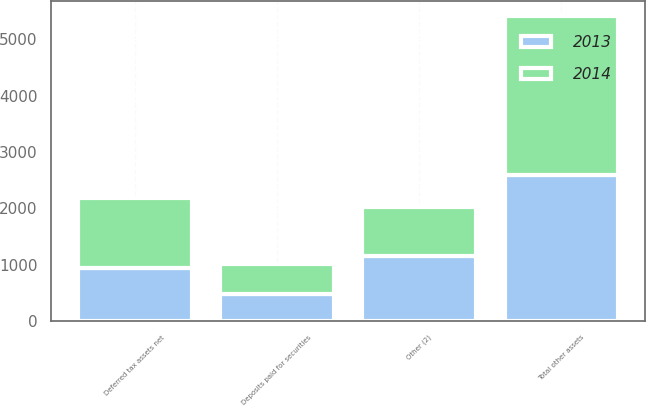Convert chart to OTSL. <chart><loc_0><loc_0><loc_500><loc_500><stacked_bar_chart><ecel><fcel>Deferred tax assets net<fcel>Deposits paid for securities<fcel>Other (2)<fcel>Total other assets<nl><fcel>2013<fcel>951<fcel>474<fcel>1158<fcel>2583<nl><fcel>2014<fcel>1239<fcel>536<fcel>869<fcel>2821<nl></chart> 